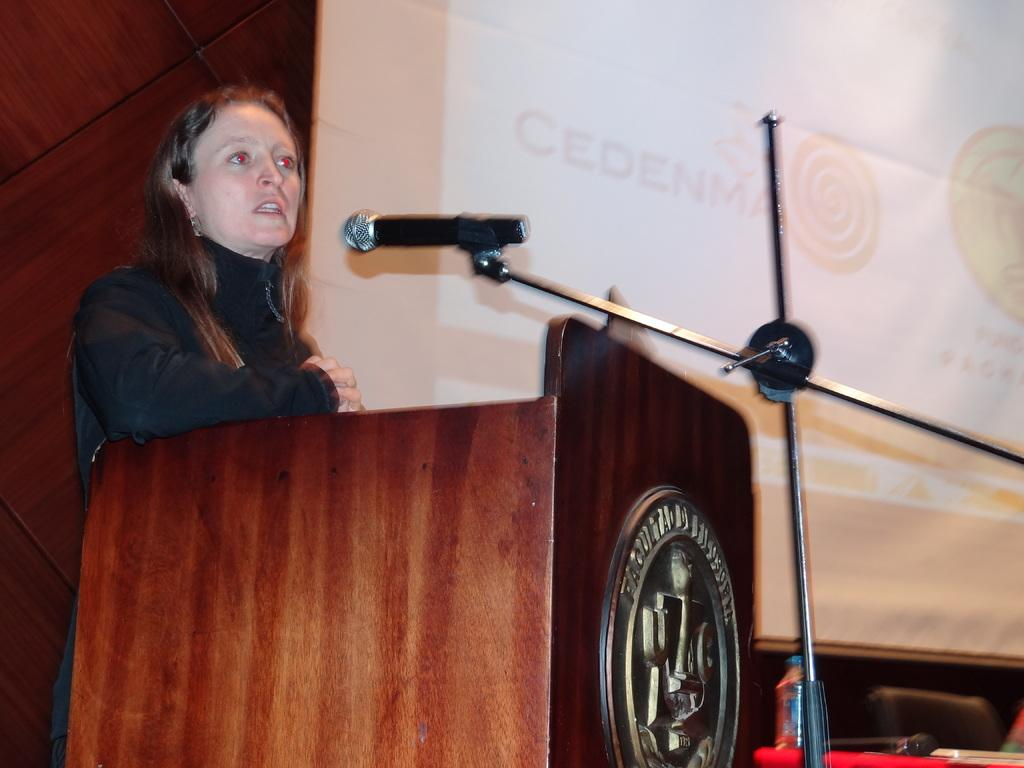Who is the main subject in the image? There is a woman in the image. What is the woman doing in the image? The woman is standing at a podium and talking on a microphone. What other objects can be seen in the image? There is a bottle, a chair, and a screen in the image. How many babies are visible in the image? There are no babies present in the image. What type of nose does the actor have in the image? There is no actor present in the image, and therefore no nose to describe. 